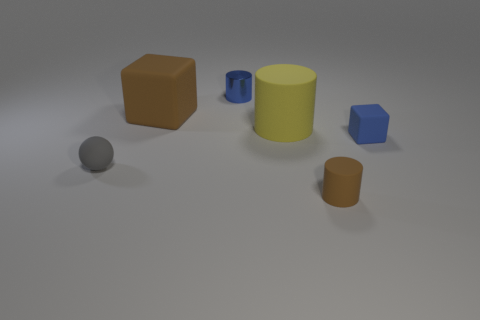Is the material of the small blue cylinder the same as the small cylinder that is right of the tiny blue cylinder?
Your answer should be very brief. No. What is the material of the gray ball?
Provide a short and direct response. Rubber. What is the material of the tiny cube that is the same color as the shiny cylinder?
Provide a succinct answer. Rubber. What number of other things are there of the same material as the tiny block
Keep it short and to the point. 4. There is a thing that is behind the small blue block and on the left side of the tiny metal cylinder; what shape is it?
Make the answer very short. Cube. There is a small cube that is the same material as the small ball; what is its color?
Keep it short and to the point. Blue. Are there an equal number of large yellow matte cylinders that are behind the tiny gray matte thing and large matte blocks?
Give a very brief answer. Yes. There is a metallic object that is the same size as the gray ball; what is its shape?
Give a very brief answer. Cylinder. What number of other objects are the same shape as the gray matte thing?
Make the answer very short. 0. There is a gray ball; is it the same size as the blue thing in front of the big brown cube?
Make the answer very short. Yes. 